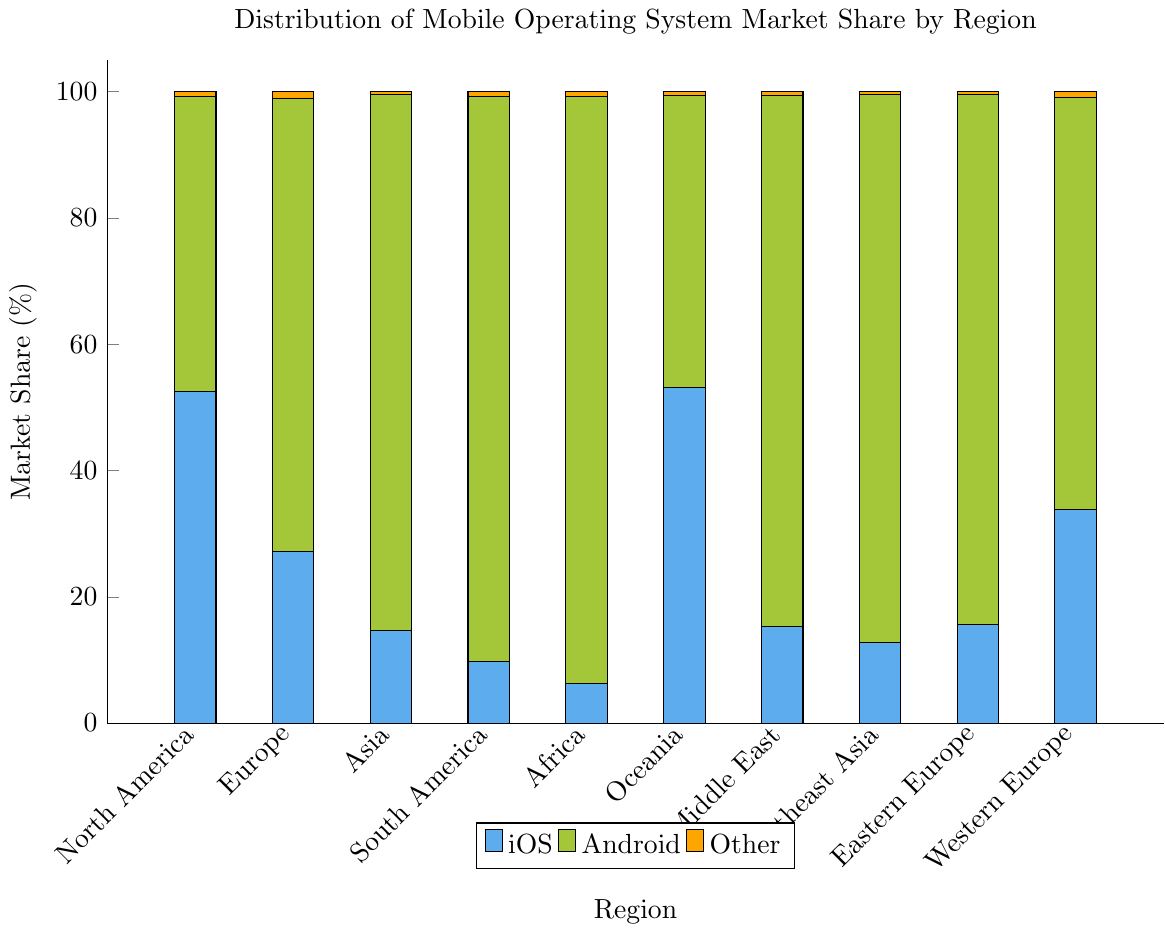Which region shows the highest market share for iOS? By examining the height of the iOS section of the stacked bar chart, Oceania has the tallest bar for iOS, indicating the highest market share for iOS.
Answer: Oceania How does the Android market share in Africa compare to South America? Looking at the height of the Android sections, Africa has a higher market share of 93.1% compared to 89.5% in South America.
Answer: Africa has a higher share What's the total market share of iOS and Other combined in North America? The iOS market share in North America is 52.5%, and Other is 0.7%. Combined, the market share is 52.5% + 0.7% = 53.2%.
Answer: 53.2% Which region has the smallest total market share for Android and Other combined? By examining and summing the Android and Other parts of the stacked bars, North America has the smallest combined market share (46.8 + 0.7 = 47.5%).
Answer: North America What's the difference in iOS market share between Western Europe and Eastern Europe? Western Europe has an iOS market share of 33.9%, and Eastern Europe has 15.6%. The difference is 33.9% - 15.6% = 18.3%.
Answer: 18.3% For how many regions is Android's market share greater than 80%? From the figure, Asia, South America, Africa, Middle East, Southeast Asia, and Eastern Europe all have Android market shares greater than 80%. That makes 6 regions.
Answer: 6 regions What's the average iOS market share across all regions? Summing the iOS market shares from all regions (52.5 + 27.2 + 14.6 + 9.8 + 6.2 + 53.1 + 15.3 + 12.7 + 15.6 + 33.9) = 241.9, then dividing by 10 regions yields an average of 24.19%.
Answer: 24.19% Which region has the second highest market share for Android? By comparing the heights of the Android sections of the bars, Asia has the highest market share (84.9%) and South America has the second highest (89.5%).
Answer: South America How much higher is the market share for Android in Asia compared to Europe? Android market share in Asia is 84.9% and in Europe is 71.8%. The difference is 84.9% - 71.8% = 13.1%.
Answer: 13.1% What is the market share of Other in any regions that have more than one percent? Only Europe has a market share of Other that is more than one percent at 1.0%.
Answer: Europe at 1.0% 